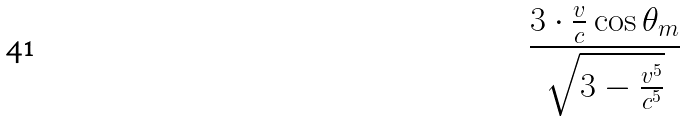Convert formula to latex. <formula><loc_0><loc_0><loc_500><loc_500>\frac { 3 \cdot \frac { v } { c } \cos \theta _ { m } } { \sqrt { 3 - \frac { v ^ { 5 } } { c ^ { 5 } } } }</formula> 